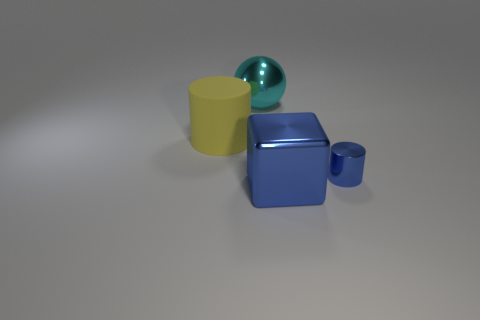Is there any other thing that has the same size as the blue cylinder?
Give a very brief answer. No. There is a large shiny object that is on the left side of the big cube; how many big blue metal objects are in front of it?
Your answer should be very brief. 1. Are there any big objects behind the large yellow thing?
Your answer should be compact. Yes. There is a big object to the right of the ball; does it have the same shape as the tiny blue metallic thing?
Your answer should be very brief. No. There is a small cylinder that is the same color as the big metallic cube; what is it made of?
Keep it short and to the point. Metal. What number of small metal things are the same color as the large cube?
Offer a terse response. 1. There is a object that is behind the cylinder behind the small blue cylinder; what is its shape?
Ensure brevity in your answer.  Sphere. Are there any other metallic objects of the same shape as the large cyan metal thing?
Offer a terse response. No. Do the cube and the cylinder behind the small metallic cylinder have the same color?
Give a very brief answer. No. What size is the metallic object that is the same color as the metal block?
Your response must be concise. Small. 